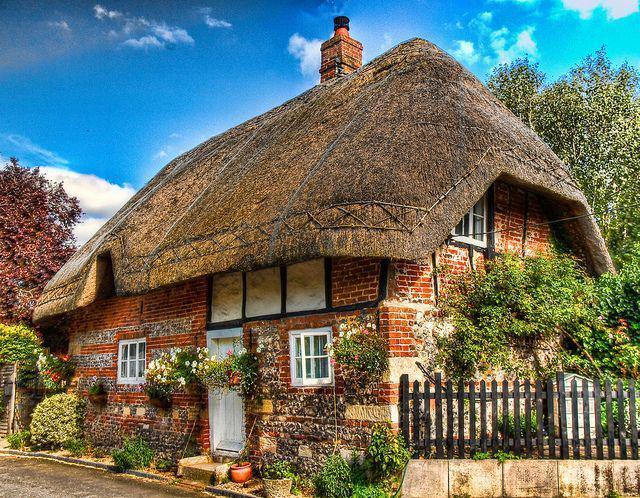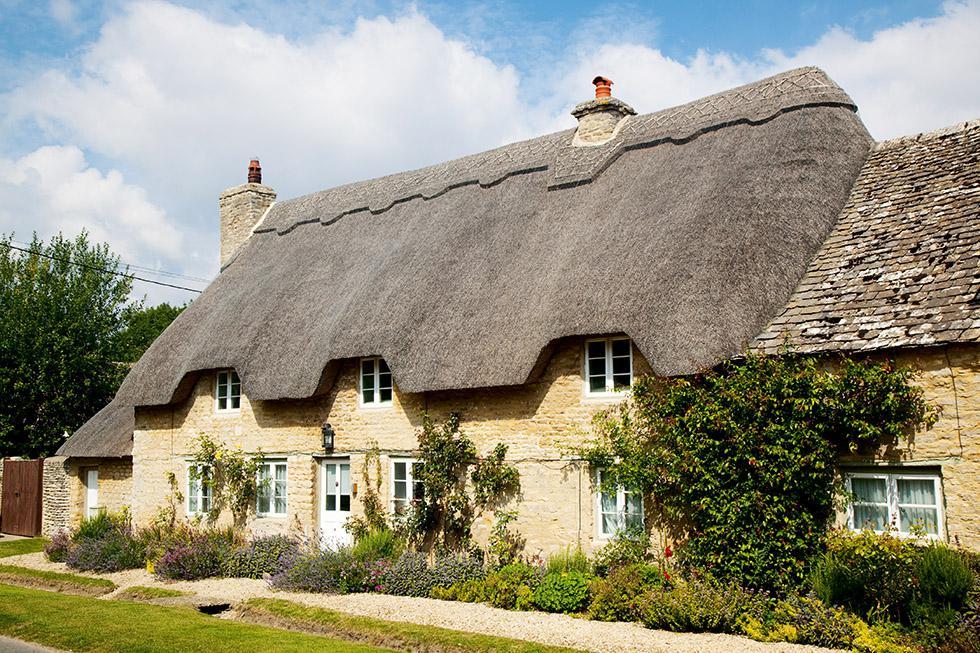The first image is the image on the left, the second image is the image on the right. For the images shown, is this caption "An image shows a chimney-less roof that curves around an upper window, creating a semicircle arch over it." true? Answer yes or no. No. The first image is the image on the left, the second image is the image on the right. Examine the images to the left and right. Is the description "In at least one image there is a a home with it's walls in red brick with at least three windows and one  chimney." accurate? Answer yes or no. Yes. 